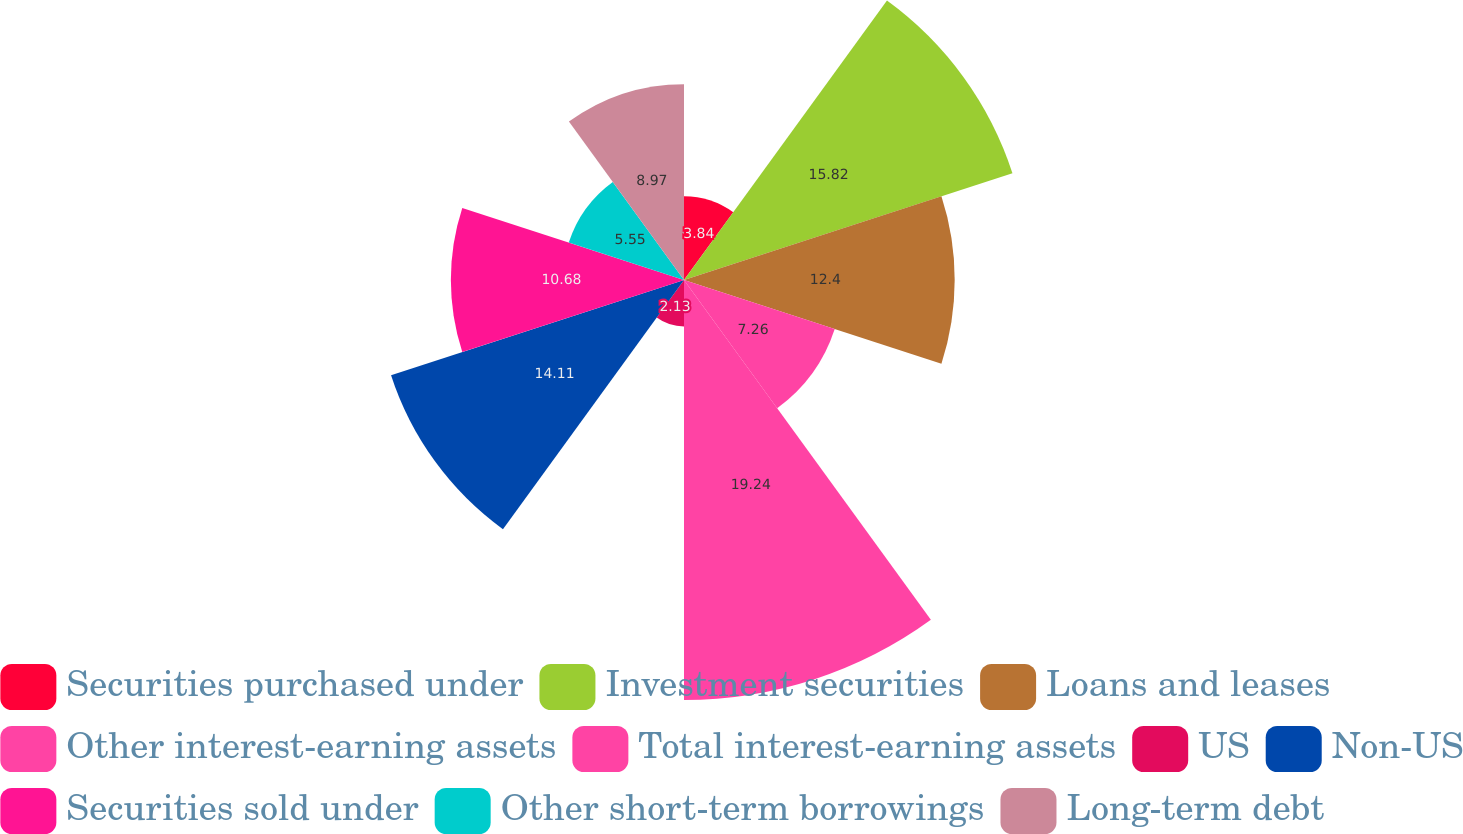Convert chart to OTSL. <chart><loc_0><loc_0><loc_500><loc_500><pie_chart><fcel>Securities purchased under<fcel>Investment securities<fcel>Loans and leases<fcel>Other interest-earning assets<fcel>Total interest-earning assets<fcel>US<fcel>Non-US<fcel>Securities sold under<fcel>Other short-term borrowings<fcel>Long-term debt<nl><fcel>3.84%<fcel>15.82%<fcel>12.4%<fcel>7.26%<fcel>19.24%<fcel>2.13%<fcel>14.11%<fcel>10.68%<fcel>5.55%<fcel>8.97%<nl></chart> 